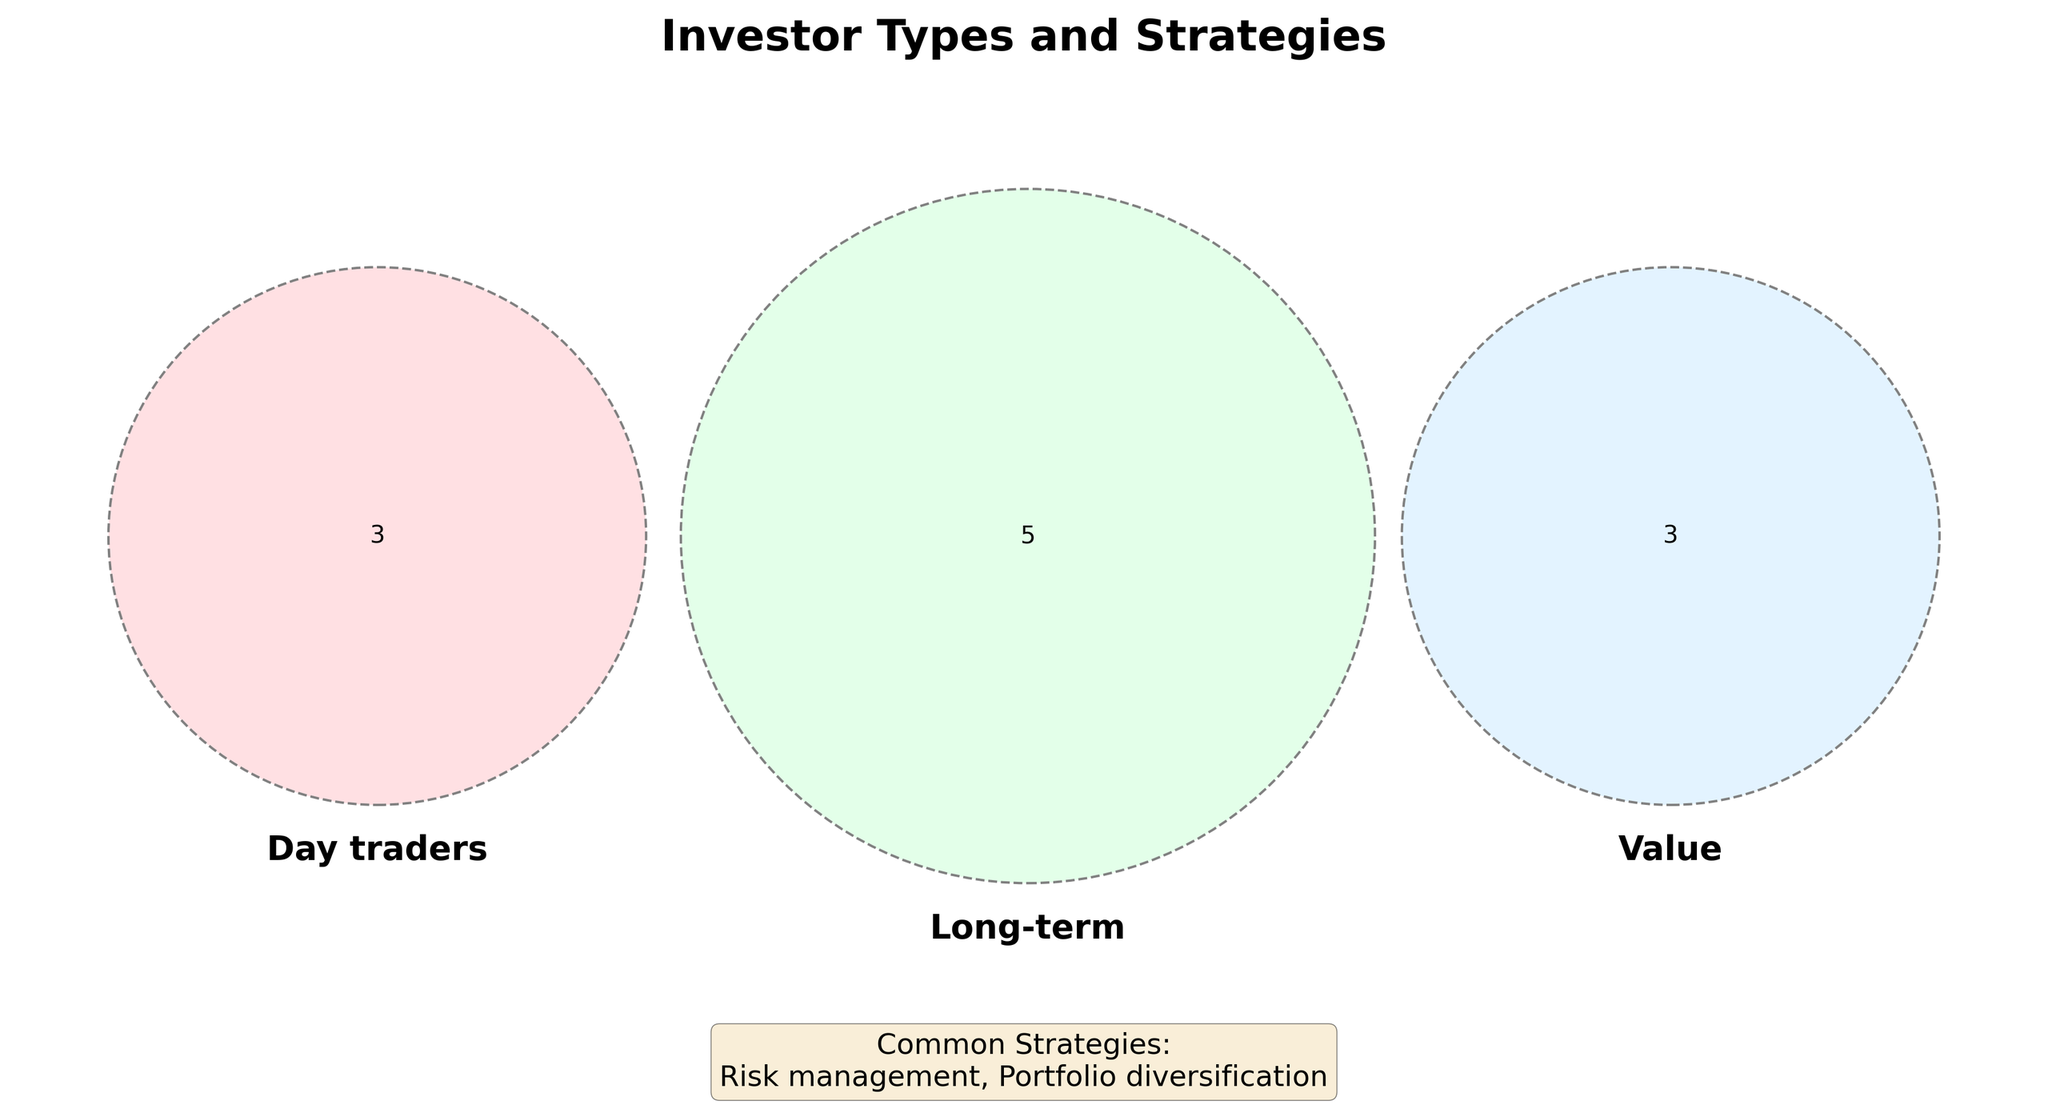What are the three investor types represented in the Venn diagram? The Venn diagram labels indicate the three investor types are 'Day traders', 'Long-term', and 'Value'.
Answer: 'Day traders', 'Long-term', 'Value' Which investor type is associated with 'Technical analysis'? In the Venn diagram, 'Technical analysis' falls within the circle representing 'Day traders'.
Answer: 'Day traders' What do 'Long-term' and 'Value' investors have in common regarding their strategies? 'Long-term' and 'Value' investors both focus on 'Dividend stocks' and 'Undervalued companies' as indicated by their overlapping sections in the Venn diagram.
Answer: 'Dividend stocks', 'Undervalued companies' Which strategies are common to all investor types? The Venn diagram's caption specifies 'Common Strategies' for all investor types as 'Risk management' and 'Portfolio diversification'.
Answer: 'Risk management', 'Portfolio diversification' Which strategy is unique to 'Long-term' investors and not shared with other types? The strategy '401(k) investments' falls exclusively under the 'Long-term' circle and is not shared with 'Day traders' or 'Value' investors.
Answer: '401(k) investments' How many unique strategies are listed only for 'Day traders'? The 'Day traders' circle contains three unique strategies: 'Quick profits', 'Market timing', and 'Technical analysis'.
Answer: Three Which strategy is employed by both 'Day traders' and 'Long-term' investors but not by 'Value' investors? The Venn diagram shows 'Tax-efficient investing' in the overlapping section between 'Day traders' and 'Long-term' investors.
Answer: 'Tax-efficient investing' Are 'Compound interest' strategies mentioned for both 'Long-term' and 'Value' investors? 'Compound interest' is listed under the 'Long-term' circle, but not mentioned in the 'Value' segment or their overlap.
Answer: No Which type of investor focuses on 'Margin of safety'? The diagram indicates 'Margin of safety' is a strategy exclusive to 'Value' investors.
Answer: 'Value' 